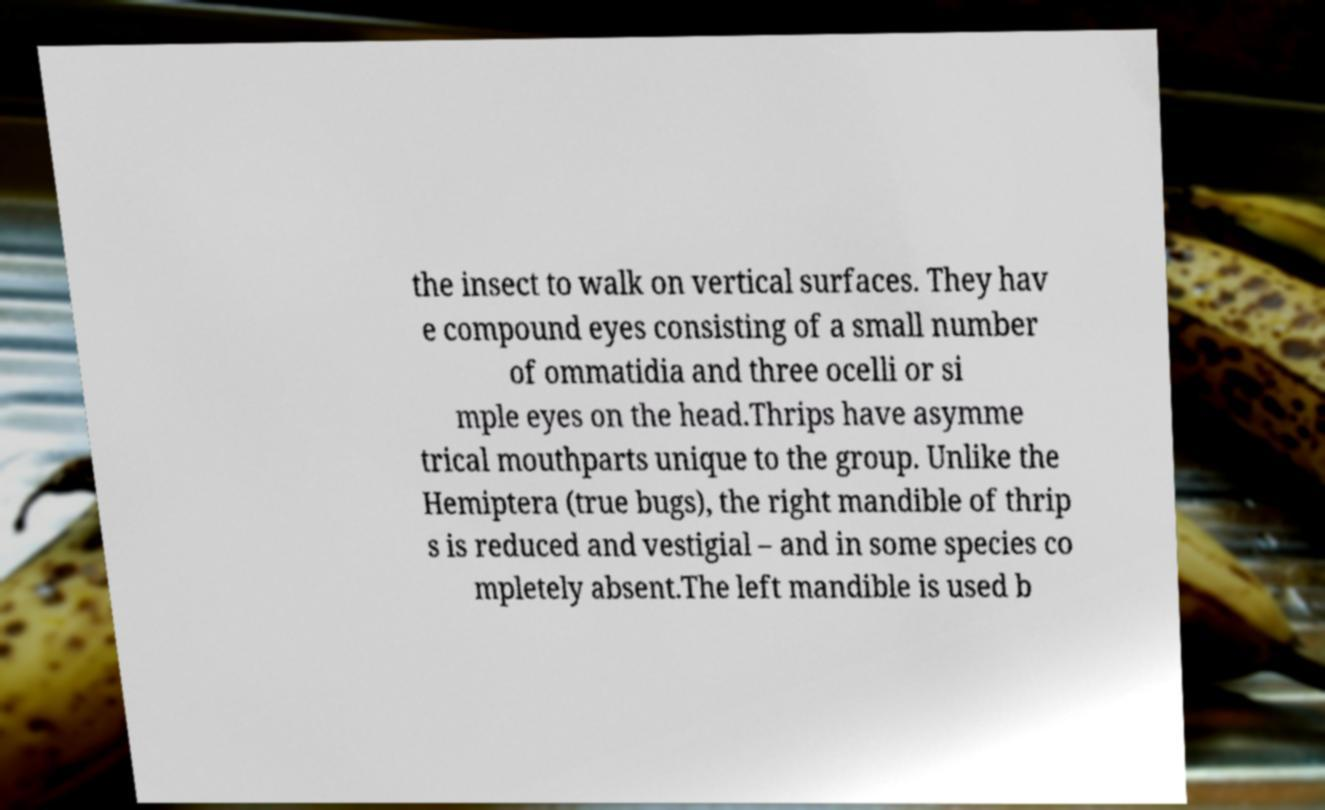There's text embedded in this image that I need extracted. Can you transcribe it verbatim? the insect to walk on vertical surfaces. They hav e compound eyes consisting of a small number of ommatidia and three ocelli or si mple eyes on the head.Thrips have asymme trical mouthparts unique to the group. Unlike the Hemiptera (true bugs), the right mandible of thrip s is reduced and vestigial – and in some species co mpletely absent.The left mandible is used b 